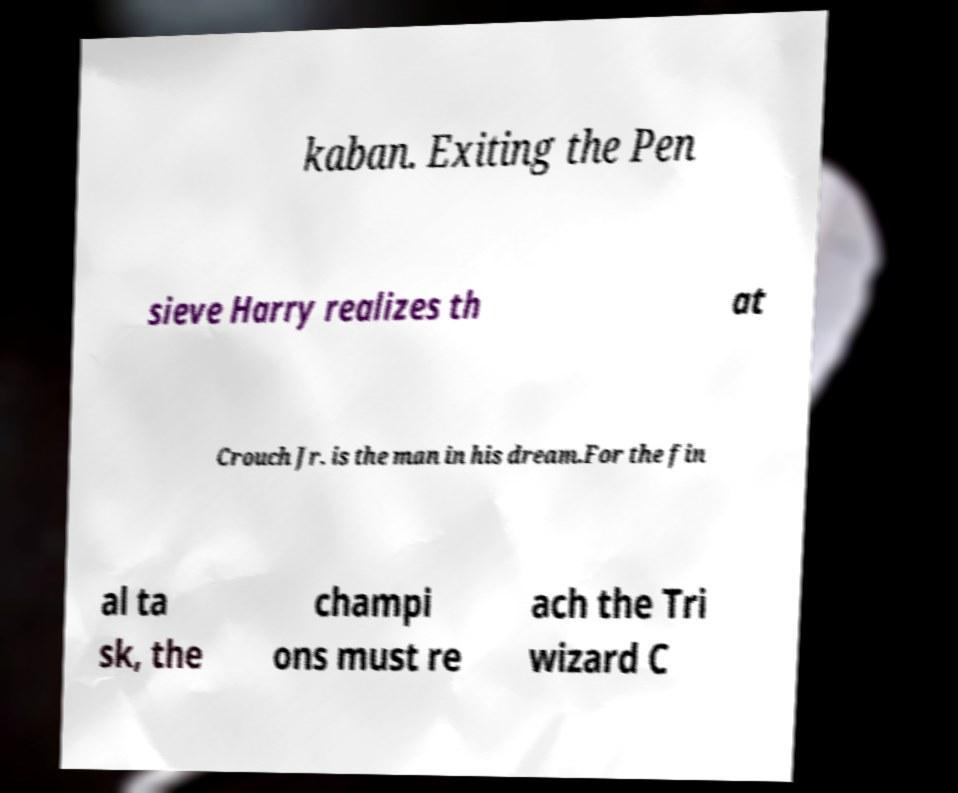There's text embedded in this image that I need extracted. Can you transcribe it verbatim? kaban. Exiting the Pen sieve Harry realizes th at Crouch Jr. is the man in his dream.For the fin al ta sk, the champi ons must re ach the Tri wizard C 